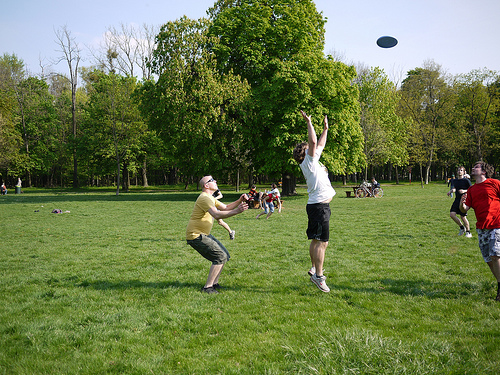Describe what you see in the image in detail. In the image, I see several individuals in a park with lush green grass and trees in the background. Two of the individuals are actively playing frisbee, with one person jumping to catch the frisbee mid-air, while another is preparing to catch it. There are more people in the background, enjoying the pleasant weather and surroundings. What do you think these people might do after playing frisbee? After playing frisbee, these people might relax on the grass, have a picnic, or continue with other outdoor activities like cycling or strolling through the park. They might also socialize, sharing stories and enjoying each other's company. 